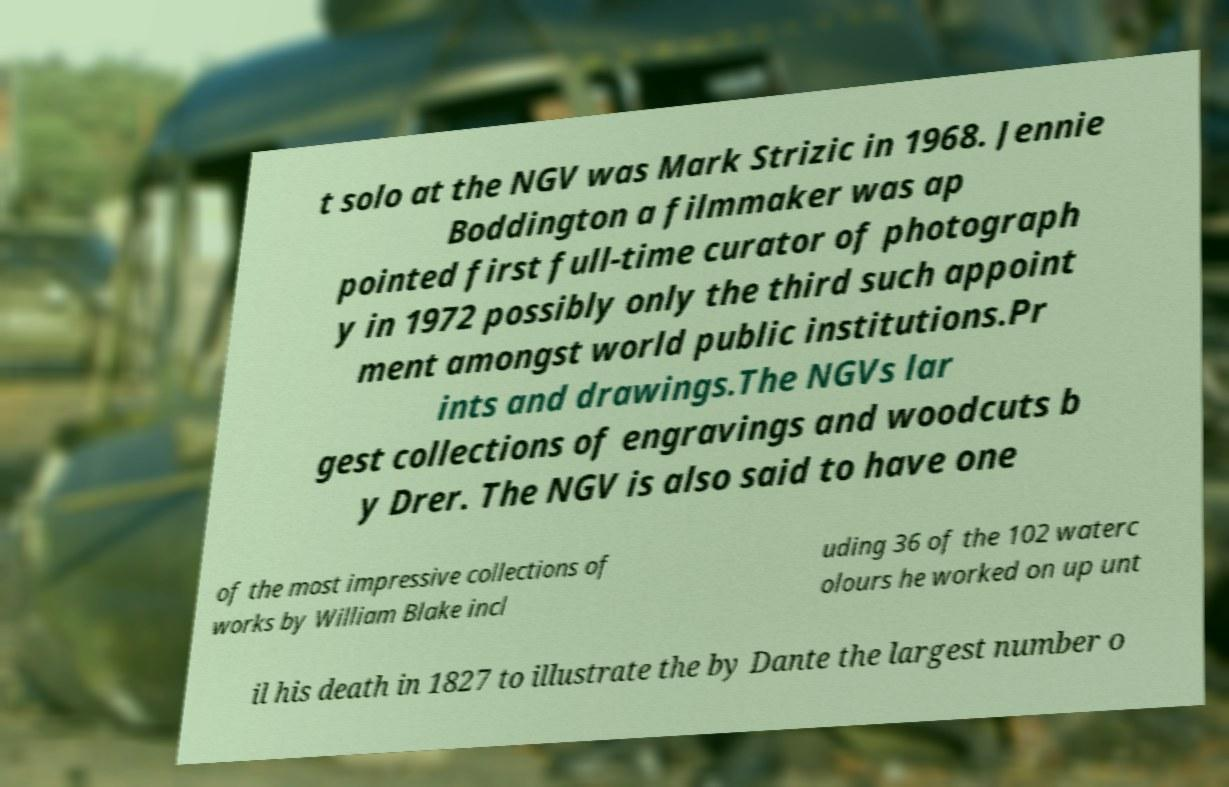For documentation purposes, I need the text within this image transcribed. Could you provide that? t solo at the NGV was Mark Strizic in 1968. Jennie Boddington a filmmaker was ap pointed first full-time curator of photograph y in 1972 possibly only the third such appoint ment amongst world public institutions.Pr ints and drawings.The NGVs lar gest collections of engravings and woodcuts b y Drer. The NGV is also said to have one of the most impressive collections of works by William Blake incl uding 36 of the 102 waterc olours he worked on up unt il his death in 1827 to illustrate the by Dante the largest number o 